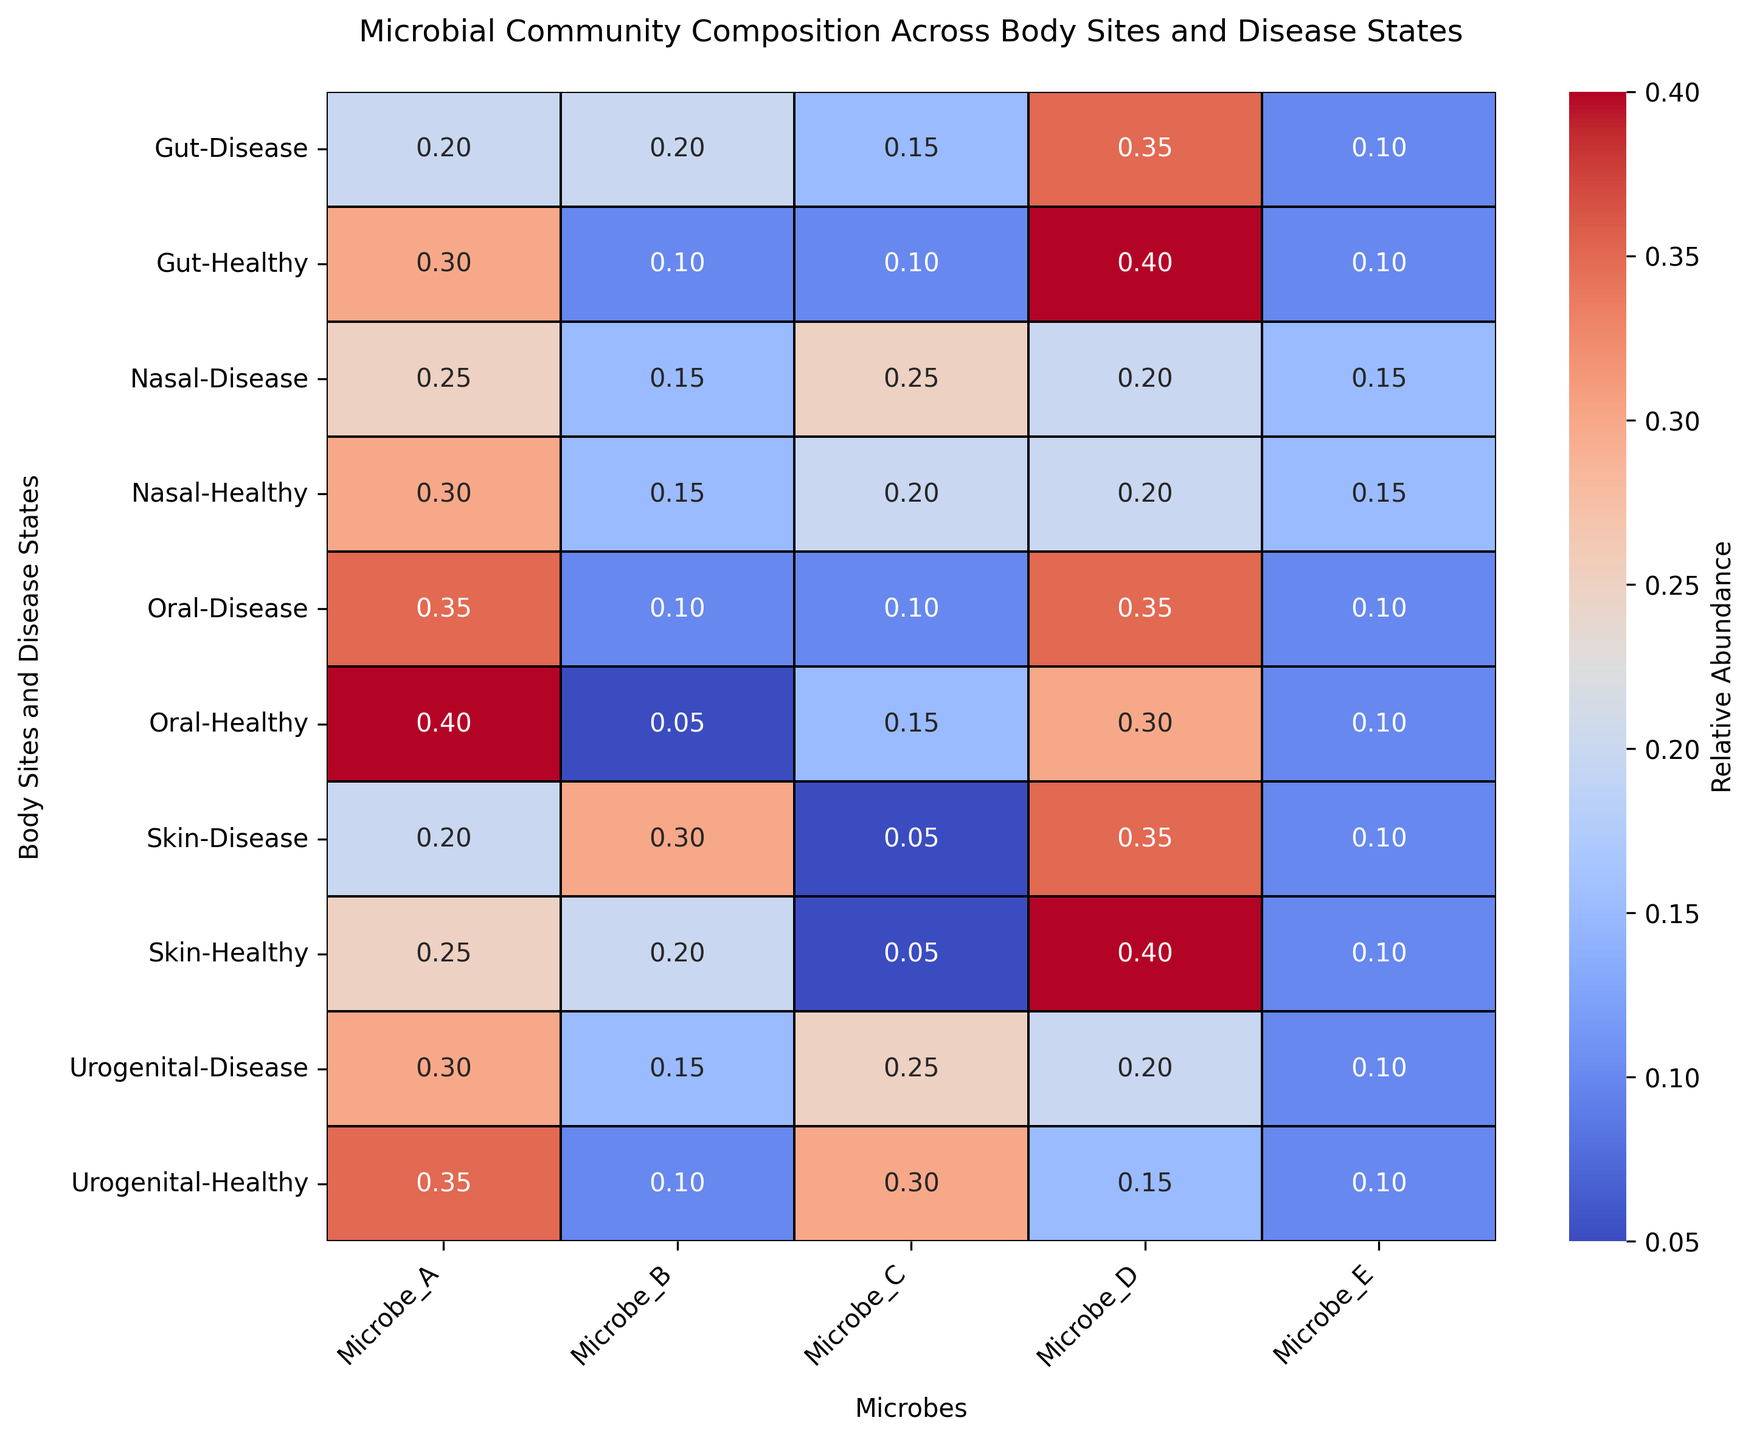Which body site shows the highest relative abundance of Microbe_D in a healthy state? Look at the row for each body site in a healthy state and identify the maximum value in the column for Microbe_D. The gut has a relative abundance of 0.4 for Microbe_D, which is the highest among all body sites.
Answer: Gut How does the relative abundance of Microbe_A in the oral site change between healthy and disease states? Compare the values of Microbe_A for the oral site in both states. In the healthy state, it is 0.4, and in the disease state, it is 0.35, indicating a decrease.
Answer: Decreases Which body site has the greatest difference in relative abundance of Microbe_B between healthy and disease states? Calculate the difference in relative abundance of Microbe_B between healthy and disease states for each body site. The skin site has the greatest difference, with values of 0.2 in a healthy state and 0.3 in a disease state, resulting in a difference of 0.1.
Answer: Skin What is the average relative abundance of Microbe_C in the nasal site across both disease states? Sum the relative abundances of Microbe_C in the nasal site for both healthy (0.2) and disease states (0.25), then divide by 2. The calculation is (0.2 + 0.25) / 2 = 0.225.
Answer: 0.225 Which microbe shows the least variation in relative abundance between the healthy and disease states across all body sites? Calculate the absolute differences in relative abundances between the healthy and disease states for each microbe and average them across all body sites. Microbe_E has consistent 0.1 abundance for all sites, indicating no variation.
Answer: Microbe_E In which body site and disease state combination is the relative abundance of Microbe_C the highest? Look across all body sites and states in the column for Microbe_C. The nasal site in the disease state has the highest observed relative abundance of 0.25.
Answer: Nasal, Disease Which microbe has the highest relative abundance in the gut site in a disease state? Look at the row for the gut in a disease state and identify the highest value. Microbe_D has the highest abundance at 0.35.
Answer: Microbe_D How does the relative abundance of Microbe_A in the urogenital site compare between healthy and disease states? Compare the value of Microbe_A in the urogenital site for healthy (0.35) and disease (0.3) states. It shows a slight decrease in the disease state.
Answer: Decreases by 0.05 